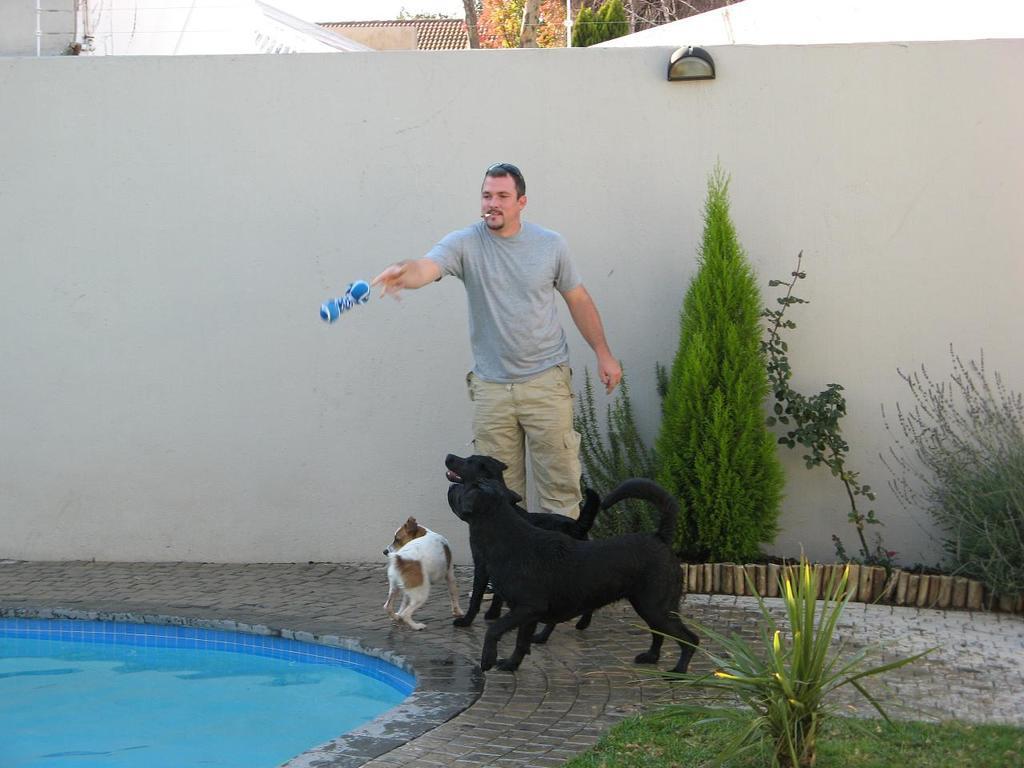How would you summarize this image in a sentence or two? In the image there is a pool, beside the pool there are dogs and a man, the man is throwing some object into the pool, around them there are plants and grass, in the background there is a wall. 